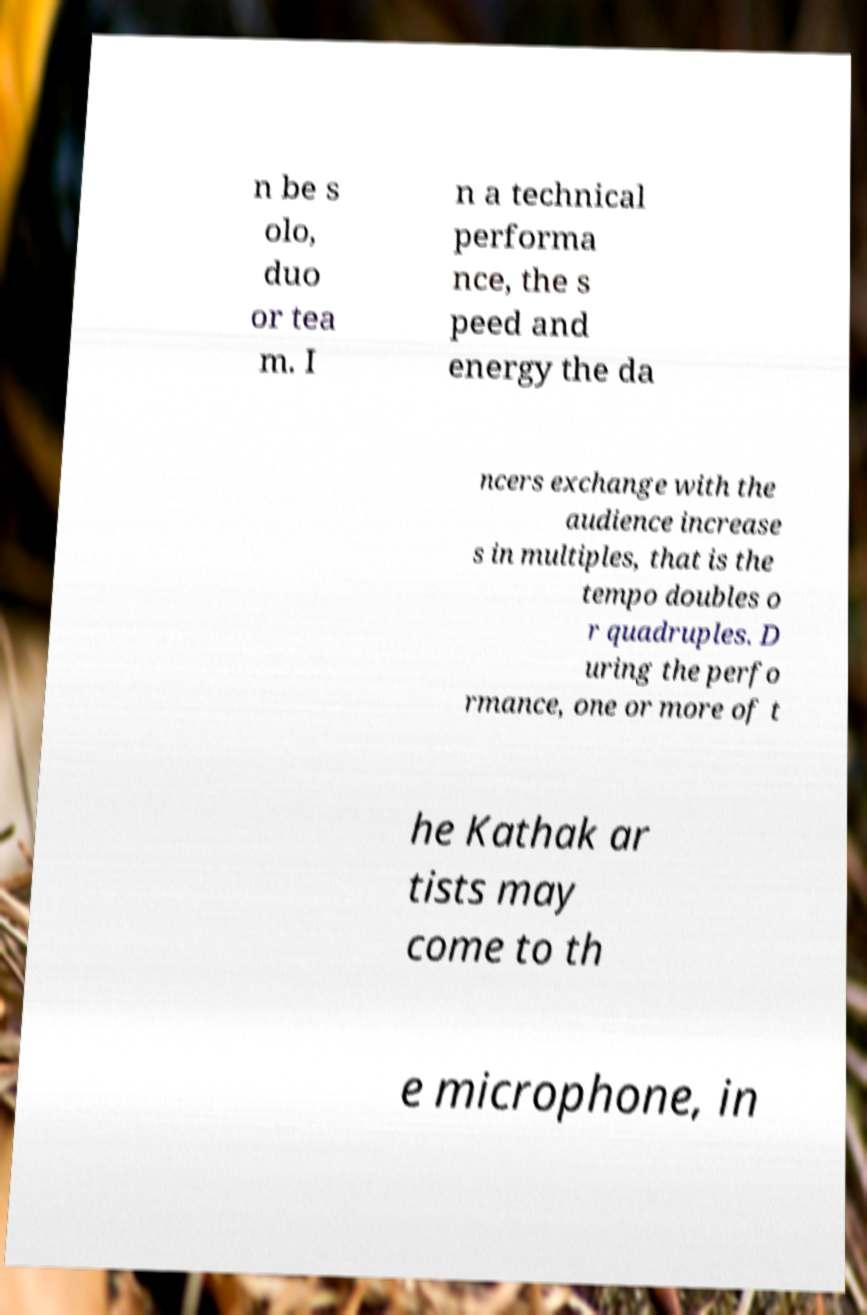Could you assist in decoding the text presented in this image and type it out clearly? n be s olo, duo or tea m. I n a technical performa nce, the s peed and energy the da ncers exchange with the audience increase s in multiples, that is the tempo doubles o r quadruples. D uring the perfo rmance, one or more of t he Kathak ar tists may come to th e microphone, in 